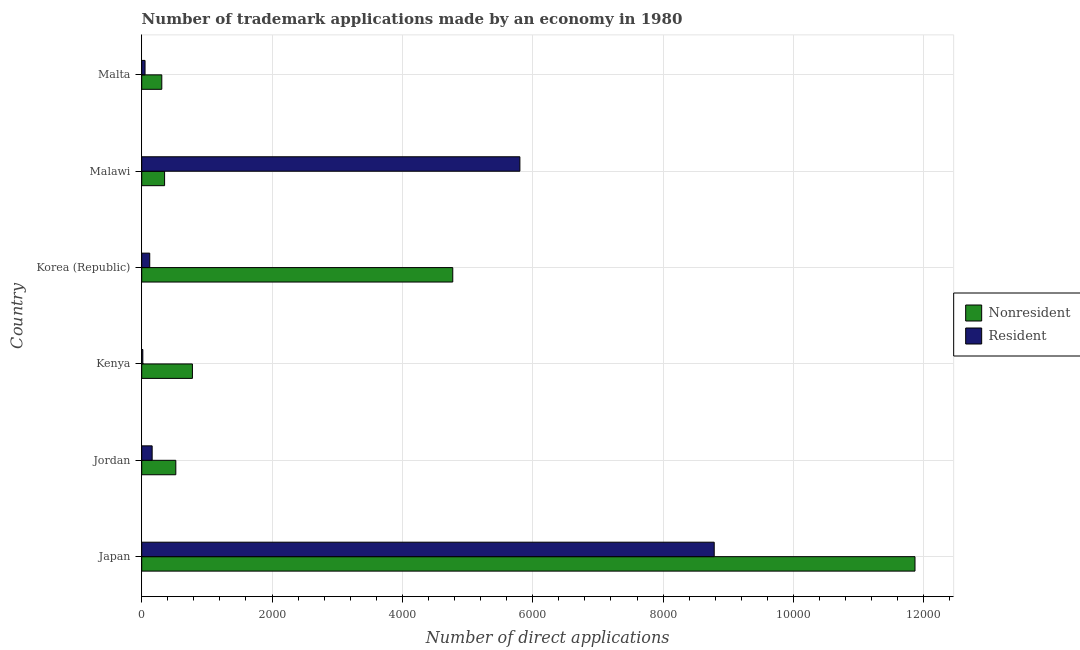Are the number of bars per tick equal to the number of legend labels?
Make the answer very short. Yes. Are the number of bars on each tick of the Y-axis equal?
Give a very brief answer. Yes. How many bars are there on the 1st tick from the bottom?
Offer a terse response. 2. What is the label of the 5th group of bars from the top?
Give a very brief answer. Jordan. In how many cases, is the number of bars for a given country not equal to the number of legend labels?
Your response must be concise. 0. What is the number of trademark applications made by non residents in Kenya?
Provide a short and direct response. 778. Across all countries, what is the maximum number of trademark applications made by residents?
Your answer should be very brief. 8785. Across all countries, what is the minimum number of trademark applications made by non residents?
Give a very brief answer. 308. In which country was the number of trademark applications made by residents maximum?
Provide a succinct answer. Japan. In which country was the number of trademark applications made by residents minimum?
Give a very brief answer. Kenya. What is the total number of trademark applications made by non residents in the graph?
Give a very brief answer. 1.86e+04. What is the difference between the number of trademark applications made by non residents in Kenya and that in Malta?
Give a very brief answer. 470. What is the difference between the number of trademark applications made by residents in Kenya and the number of trademark applications made by non residents in Korea (Republic)?
Ensure brevity in your answer.  -4756. What is the average number of trademark applications made by non residents per country?
Offer a terse response. 3099.83. What is the difference between the number of trademark applications made by residents and number of trademark applications made by non residents in Malawi?
Ensure brevity in your answer.  5452. In how many countries, is the number of trademark applications made by residents greater than 10400 ?
Your answer should be compact. 0. What is the ratio of the number of trademark applications made by non residents in Jordan to that in Malawi?
Your response must be concise. 1.49. Is the number of trademark applications made by residents in Japan less than that in Malta?
Your answer should be compact. No. Is the difference between the number of trademark applications made by non residents in Kenya and Korea (Republic) greater than the difference between the number of trademark applications made by residents in Kenya and Korea (Republic)?
Make the answer very short. No. What is the difference between the highest and the second highest number of trademark applications made by residents?
Provide a short and direct response. 2982. What is the difference between the highest and the lowest number of trademark applications made by residents?
Ensure brevity in your answer.  8768. In how many countries, is the number of trademark applications made by residents greater than the average number of trademark applications made by residents taken over all countries?
Make the answer very short. 2. What does the 2nd bar from the top in Kenya represents?
Your answer should be very brief. Nonresident. What does the 2nd bar from the bottom in Jordan represents?
Offer a very short reply. Resident. How many bars are there?
Provide a succinct answer. 12. Are all the bars in the graph horizontal?
Make the answer very short. Yes. What is the difference between two consecutive major ticks on the X-axis?
Provide a succinct answer. 2000. Does the graph contain any zero values?
Your response must be concise. No. How many legend labels are there?
Make the answer very short. 2. How are the legend labels stacked?
Your response must be concise. Vertical. What is the title of the graph?
Ensure brevity in your answer.  Number of trademark applications made by an economy in 1980. Does "% of GNI" appear as one of the legend labels in the graph?
Ensure brevity in your answer.  No. What is the label or title of the X-axis?
Make the answer very short. Number of direct applications. What is the Number of direct applications in Nonresident in Japan?
Your response must be concise. 1.19e+04. What is the Number of direct applications in Resident in Japan?
Keep it short and to the point. 8785. What is the Number of direct applications of Nonresident in Jordan?
Give a very brief answer. 523. What is the Number of direct applications of Resident in Jordan?
Make the answer very short. 160. What is the Number of direct applications of Nonresident in Kenya?
Your answer should be very brief. 778. What is the Number of direct applications of Nonresident in Korea (Republic)?
Your response must be concise. 4773. What is the Number of direct applications of Resident in Korea (Republic)?
Provide a succinct answer. 123. What is the Number of direct applications of Nonresident in Malawi?
Ensure brevity in your answer.  351. What is the Number of direct applications in Resident in Malawi?
Ensure brevity in your answer.  5803. What is the Number of direct applications in Nonresident in Malta?
Ensure brevity in your answer.  308. Across all countries, what is the maximum Number of direct applications of Nonresident?
Your response must be concise. 1.19e+04. Across all countries, what is the maximum Number of direct applications of Resident?
Make the answer very short. 8785. Across all countries, what is the minimum Number of direct applications in Nonresident?
Make the answer very short. 308. Across all countries, what is the minimum Number of direct applications in Resident?
Your answer should be compact. 17. What is the total Number of direct applications in Nonresident in the graph?
Provide a succinct answer. 1.86e+04. What is the total Number of direct applications of Resident in the graph?
Offer a very short reply. 1.49e+04. What is the difference between the Number of direct applications of Nonresident in Japan and that in Jordan?
Give a very brief answer. 1.13e+04. What is the difference between the Number of direct applications in Resident in Japan and that in Jordan?
Keep it short and to the point. 8625. What is the difference between the Number of direct applications of Nonresident in Japan and that in Kenya?
Your answer should be very brief. 1.11e+04. What is the difference between the Number of direct applications in Resident in Japan and that in Kenya?
Your answer should be compact. 8768. What is the difference between the Number of direct applications in Nonresident in Japan and that in Korea (Republic)?
Keep it short and to the point. 7093. What is the difference between the Number of direct applications of Resident in Japan and that in Korea (Republic)?
Your response must be concise. 8662. What is the difference between the Number of direct applications of Nonresident in Japan and that in Malawi?
Your response must be concise. 1.15e+04. What is the difference between the Number of direct applications of Resident in Japan and that in Malawi?
Offer a terse response. 2982. What is the difference between the Number of direct applications in Nonresident in Japan and that in Malta?
Give a very brief answer. 1.16e+04. What is the difference between the Number of direct applications of Resident in Japan and that in Malta?
Your answer should be very brief. 8734. What is the difference between the Number of direct applications of Nonresident in Jordan and that in Kenya?
Give a very brief answer. -255. What is the difference between the Number of direct applications of Resident in Jordan and that in Kenya?
Provide a succinct answer. 143. What is the difference between the Number of direct applications of Nonresident in Jordan and that in Korea (Republic)?
Offer a very short reply. -4250. What is the difference between the Number of direct applications of Resident in Jordan and that in Korea (Republic)?
Keep it short and to the point. 37. What is the difference between the Number of direct applications of Nonresident in Jordan and that in Malawi?
Offer a terse response. 172. What is the difference between the Number of direct applications in Resident in Jordan and that in Malawi?
Ensure brevity in your answer.  -5643. What is the difference between the Number of direct applications of Nonresident in Jordan and that in Malta?
Ensure brevity in your answer.  215. What is the difference between the Number of direct applications of Resident in Jordan and that in Malta?
Offer a very short reply. 109. What is the difference between the Number of direct applications in Nonresident in Kenya and that in Korea (Republic)?
Keep it short and to the point. -3995. What is the difference between the Number of direct applications in Resident in Kenya and that in Korea (Republic)?
Keep it short and to the point. -106. What is the difference between the Number of direct applications of Nonresident in Kenya and that in Malawi?
Keep it short and to the point. 427. What is the difference between the Number of direct applications in Resident in Kenya and that in Malawi?
Make the answer very short. -5786. What is the difference between the Number of direct applications in Nonresident in Kenya and that in Malta?
Provide a succinct answer. 470. What is the difference between the Number of direct applications in Resident in Kenya and that in Malta?
Provide a succinct answer. -34. What is the difference between the Number of direct applications of Nonresident in Korea (Republic) and that in Malawi?
Your response must be concise. 4422. What is the difference between the Number of direct applications of Resident in Korea (Republic) and that in Malawi?
Give a very brief answer. -5680. What is the difference between the Number of direct applications in Nonresident in Korea (Republic) and that in Malta?
Provide a short and direct response. 4465. What is the difference between the Number of direct applications of Resident in Malawi and that in Malta?
Give a very brief answer. 5752. What is the difference between the Number of direct applications of Nonresident in Japan and the Number of direct applications of Resident in Jordan?
Your answer should be very brief. 1.17e+04. What is the difference between the Number of direct applications of Nonresident in Japan and the Number of direct applications of Resident in Kenya?
Provide a succinct answer. 1.18e+04. What is the difference between the Number of direct applications of Nonresident in Japan and the Number of direct applications of Resident in Korea (Republic)?
Offer a terse response. 1.17e+04. What is the difference between the Number of direct applications of Nonresident in Japan and the Number of direct applications of Resident in Malawi?
Keep it short and to the point. 6063. What is the difference between the Number of direct applications in Nonresident in Japan and the Number of direct applications in Resident in Malta?
Your response must be concise. 1.18e+04. What is the difference between the Number of direct applications in Nonresident in Jordan and the Number of direct applications in Resident in Kenya?
Offer a very short reply. 506. What is the difference between the Number of direct applications of Nonresident in Jordan and the Number of direct applications of Resident in Malawi?
Keep it short and to the point. -5280. What is the difference between the Number of direct applications in Nonresident in Jordan and the Number of direct applications in Resident in Malta?
Provide a short and direct response. 472. What is the difference between the Number of direct applications of Nonresident in Kenya and the Number of direct applications of Resident in Korea (Republic)?
Ensure brevity in your answer.  655. What is the difference between the Number of direct applications of Nonresident in Kenya and the Number of direct applications of Resident in Malawi?
Offer a very short reply. -5025. What is the difference between the Number of direct applications of Nonresident in Kenya and the Number of direct applications of Resident in Malta?
Give a very brief answer. 727. What is the difference between the Number of direct applications of Nonresident in Korea (Republic) and the Number of direct applications of Resident in Malawi?
Offer a very short reply. -1030. What is the difference between the Number of direct applications in Nonresident in Korea (Republic) and the Number of direct applications in Resident in Malta?
Provide a short and direct response. 4722. What is the difference between the Number of direct applications in Nonresident in Malawi and the Number of direct applications in Resident in Malta?
Provide a succinct answer. 300. What is the average Number of direct applications in Nonresident per country?
Offer a very short reply. 3099.83. What is the average Number of direct applications of Resident per country?
Your answer should be compact. 2489.83. What is the difference between the Number of direct applications of Nonresident and Number of direct applications of Resident in Japan?
Make the answer very short. 3081. What is the difference between the Number of direct applications in Nonresident and Number of direct applications in Resident in Jordan?
Your response must be concise. 363. What is the difference between the Number of direct applications in Nonresident and Number of direct applications in Resident in Kenya?
Offer a very short reply. 761. What is the difference between the Number of direct applications of Nonresident and Number of direct applications of Resident in Korea (Republic)?
Your answer should be compact. 4650. What is the difference between the Number of direct applications in Nonresident and Number of direct applications in Resident in Malawi?
Provide a short and direct response. -5452. What is the difference between the Number of direct applications of Nonresident and Number of direct applications of Resident in Malta?
Make the answer very short. 257. What is the ratio of the Number of direct applications in Nonresident in Japan to that in Jordan?
Give a very brief answer. 22.69. What is the ratio of the Number of direct applications in Resident in Japan to that in Jordan?
Your answer should be compact. 54.91. What is the ratio of the Number of direct applications of Nonresident in Japan to that in Kenya?
Give a very brief answer. 15.25. What is the ratio of the Number of direct applications of Resident in Japan to that in Kenya?
Provide a short and direct response. 516.76. What is the ratio of the Number of direct applications of Nonresident in Japan to that in Korea (Republic)?
Your response must be concise. 2.49. What is the ratio of the Number of direct applications in Resident in Japan to that in Korea (Republic)?
Your response must be concise. 71.42. What is the ratio of the Number of direct applications in Nonresident in Japan to that in Malawi?
Offer a very short reply. 33.81. What is the ratio of the Number of direct applications of Resident in Japan to that in Malawi?
Offer a terse response. 1.51. What is the ratio of the Number of direct applications of Nonresident in Japan to that in Malta?
Ensure brevity in your answer.  38.53. What is the ratio of the Number of direct applications in Resident in Japan to that in Malta?
Provide a succinct answer. 172.25. What is the ratio of the Number of direct applications in Nonresident in Jordan to that in Kenya?
Provide a short and direct response. 0.67. What is the ratio of the Number of direct applications in Resident in Jordan to that in Kenya?
Ensure brevity in your answer.  9.41. What is the ratio of the Number of direct applications of Nonresident in Jordan to that in Korea (Republic)?
Your answer should be compact. 0.11. What is the ratio of the Number of direct applications of Resident in Jordan to that in Korea (Republic)?
Your response must be concise. 1.3. What is the ratio of the Number of direct applications of Nonresident in Jordan to that in Malawi?
Your response must be concise. 1.49. What is the ratio of the Number of direct applications of Resident in Jordan to that in Malawi?
Your response must be concise. 0.03. What is the ratio of the Number of direct applications in Nonresident in Jordan to that in Malta?
Provide a succinct answer. 1.7. What is the ratio of the Number of direct applications of Resident in Jordan to that in Malta?
Offer a very short reply. 3.14. What is the ratio of the Number of direct applications in Nonresident in Kenya to that in Korea (Republic)?
Make the answer very short. 0.16. What is the ratio of the Number of direct applications in Resident in Kenya to that in Korea (Republic)?
Give a very brief answer. 0.14. What is the ratio of the Number of direct applications of Nonresident in Kenya to that in Malawi?
Make the answer very short. 2.22. What is the ratio of the Number of direct applications of Resident in Kenya to that in Malawi?
Give a very brief answer. 0. What is the ratio of the Number of direct applications of Nonresident in Kenya to that in Malta?
Offer a very short reply. 2.53. What is the ratio of the Number of direct applications in Resident in Kenya to that in Malta?
Provide a succinct answer. 0.33. What is the ratio of the Number of direct applications of Nonresident in Korea (Republic) to that in Malawi?
Keep it short and to the point. 13.6. What is the ratio of the Number of direct applications of Resident in Korea (Republic) to that in Malawi?
Ensure brevity in your answer.  0.02. What is the ratio of the Number of direct applications of Nonresident in Korea (Republic) to that in Malta?
Your answer should be very brief. 15.5. What is the ratio of the Number of direct applications in Resident in Korea (Republic) to that in Malta?
Your response must be concise. 2.41. What is the ratio of the Number of direct applications in Nonresident in Malawi to that in Malta?
Your answer should be compact. 1.14. What is the ratio of the Number of direct applications in Resident in Malawi to that in Malta?
Provide a short and direct response. 113.78. What is the difference between the highest and the second highest Number of direct applications of Nonresident?
Offer a terse response. 7093. What is the difference between the highest and the second highest Number of direct applications of Resident?
Make the answer very short. 2982. What is the difference between the highest and the lowest Number of direct applications of Nonresident?
Make the answer very short. 1.16e+04. What is the difference between the highest and the lowest Number of direct applications of Resident?
Give a very brief answer. 8768. 